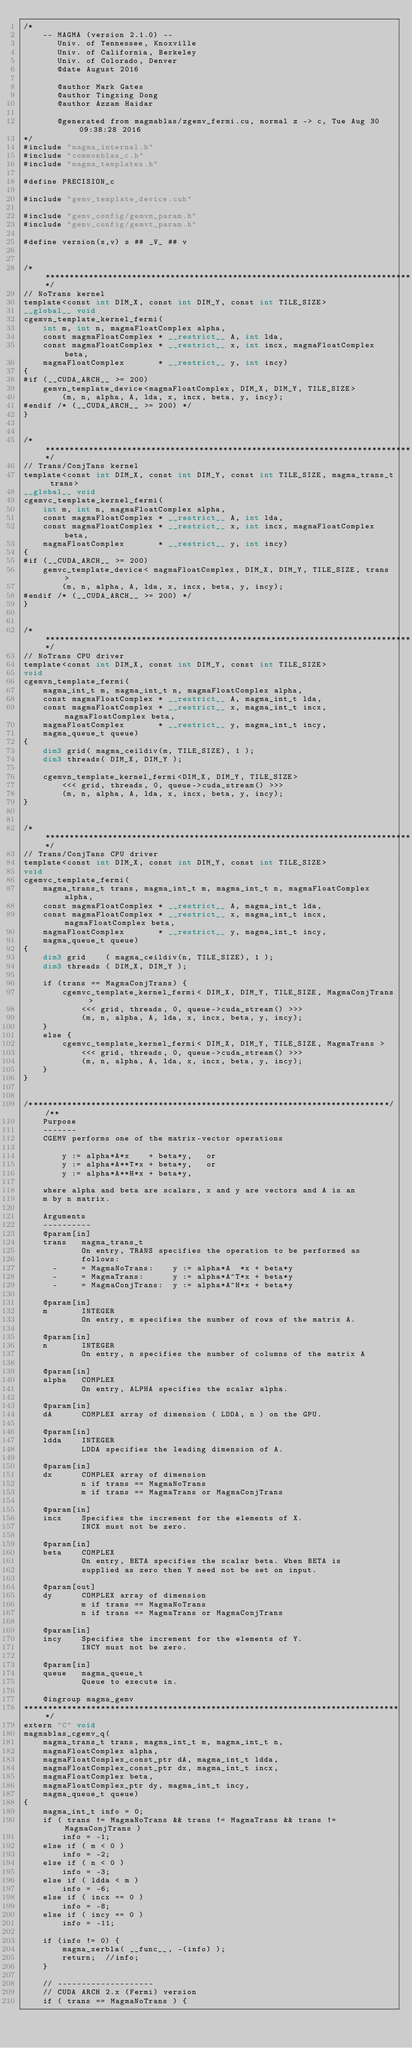Convert code to text. <code><loc_0><loc_0><loc_500><loc_500><_Cuda_>/*
    -- MAGMA (version 2.1.0) --
       Univ. of Tennessee, Knoxville
       Univ. of California, Berkeley
       Univ. of Colorado, Denver
       @date August 2016
       
       @author Mark Gates
       @author Tingxing Dong
       @author Azzam Haidar

       @generated from magmablas/zgemv_fermi.cu, normal z -> c, Tue Aug 30 09:38:28 2016
*/
#include "magma_internal.h"
#include "commonblas_c.h"
#include "magma_templates.h"

#define PRECISION_c

#include "gemv_template_device.cuh"

#include "gemv_config/gemvn_param.h"
#include "gemv_config/gemvt_param.h"

#define version(s,v) s ## _V_ ## v


/******************************************************************************/
// NoTrans kernel
template<const int DIM_X, const int DIM_Y, const int TILE_SIZE>
__global__ void
cgemvn_template_kernel_fermi(
    int m, int n, magmaFloatComplex alpha,
    const magmaFloatComplex * __restrict__ A, int lda,
    const magmaFloatComplex * __restrict__ x, int incx, magmaFloatComplex beta,
    magmaFloatComplex       * __restrict__ y, int incy)
{
#if (__CUDA_ARCH__ >= 200)
    gemvn_template_device<magmaFloatComplex, DIM_X, DIM_Y, TILE_SIZE>
        (m, n, alpha, A, lda, x, incx, beta, y, incy);
#endif /* (__CUDA_ARCH__ >= 200) */
}


/******************************************************************************/
// Trans/ConjTans kernel
template<const int DIM_X, const int DIM_Y, const int TILE_SIZE, magma_trans_t trans>
__global__ void
cgemvc_template_kernel_fermi(
    int m, int n, magmaFloatComplex alpha,
    const magmaFloatComplex * __restrict__ A, int lda,
    const magmaFloatComplex * __restrict__ x, int incx, magmaFloatComplex beta,
    magmaFloatComplex       * __restrict__ y, int incy)
{
#if (__CUDA_ARCH__ >= 200)
    gemvc_template_device< magmaFloatComplex, DIM_X, DIM_Y, TILE_SIZE, trans >
        (m, n, alpha, A, lda, x, incx, beta, y, incy);
#endif /* (__CUDA_ARCH__ >= 200) */
}


/******************************************************************************/
// NoTrans CPU driver
template<const int DIM_X, const int DIM_Y, const int TILE_SIZE>
void
cgemvn_template_fermi(
    magma_int_t m, magma_int_t n, magmaFloatComplex alpha,
    const magmaFloatComplex * __restrict__ A, magma_int_t lda,
    const magmaFloatComplex * __restrict__ x, magma_int_t incx, magmaFloatComplex beta,
    magmaFloatComplex       * __restrict__ y, magma_int_t incy,
    magma_queue_t queue)
{
    dim3 grid( magma_ceildiv(m, TILE_SIZE), 1 );
    dim3 threads( DIM_X, DIM_Y );

    cgemvn_template_kernel_fermi<DIM_X, DIM_Y, TILE_SIZE>
        <<< grid, threads, 0, queue->cuda_stream() >>>
        (m, n, alpha, A, lda, x, incx, beta, y, incy);
}


/******************************************************************************/
// Trans/ConjTans CPU driver
template<const int DIM_X, const int DIM_Y, const int TILE_SIZE>
void
cgemvc_template_fermi(
    magma_trans_t trans, magma_int_t m, magma_int_t n, magmaFloatComplex alpha,
    const magmaFloatComplex * __restrict__ A, magma_int_t lda,
    const magmaFloatComplex * __restrict__ x, magma_int_t incx, magmaFloatComplex beta,
    magmaFloatComplex       * __restrict__ y, magma_int_t incy,
    magma_queue_t queue)
{
    dim3 grid    ( magma_ceildiv(n, TILE_SIZE), 1 );
    dim3 threads ( DIM_X, DIM_Y );
    
    if (trans == MagmaConjTrans) {
        cgemvc_template_kernel_fermi< DIM_X, DIM_Y, TILE_SIZE, MagmaConjTrans >
            <<< grid, threads, 0, queue->cuda_stream() >>>
            (m, n, alpha, A, lda, x, incx, beta, y, incy);
    }
    else {
        cgemvc_template_kernel_fermi< DIM_X, DIM_Y, TILE_SIZE, MagmaTrans >
            <<< grid, threads, 0, queue->cuda_stream() >>>
            (m, n, alpha, A, lda, x, incx, beta, y, incy);
    }
}


/***************************************************************************//**
    Purpose
    -------
    CGEMV performs one of the matrix-vector operations
    
        y := alpha*A*x    + beta*y,   or
        y := alpha*A**T*x + beta*y,   or
        y := alpha*A**H*x + beta*y,
    
    where alpha and beta are scalars, x and y are vectors and A is an
    m by n matrix.

    Arguments
    ----------
    @param[in]
    trans   magma_trans_t
            On entry, TRANS specifies the operation to be performed as
            follows:
      -     = MagmaNoTrans:    y := alpha*A  *x + beta*y
      -     = MagmaTrans:      y := alpha*A^T*x + beta*y
      -     = MagmaConjTrans:  y := alpha*A^H*x + beta*y

    @param[in]
    m       INTEGER
            On entry, m specifies the number of rows of the matrix A.

    @param[in]
    n       INTEGER
            On entry, n specifies the number of columns of the matrix A
 
    @param[in]
    alpha   COMPLEX
            On entry, ALPHA specifies the scalar alpha.

    @param[in]
    dA      COMPLEX array of dimension ( LDDA, n ) on the GPU.
   
    @param[in]
    ldda    INTEGER
            LDDA specifies the leading dimension of A.

    @param[in]
    dx      COMPLEX array of dimension
            n if trans == MagmaNoTrans
            m if trans == MagmaTrans or MagmaConjTrans
     
    @param[in]
    incx    Specifies the increment for the elements of X.
            INCX must not be zero.
  
    @param[in]
    beta    COMPLEX
            On entry, BETA specifies the scalar beta. When BETA is
            supplied as zero then Y need not be set on input.

    @param[out]
    dy      COMPLEX array of dimension
            m if trans == MagmaNoTrans
            n if trans == MagmaTrans or MagmaConjTrans

    @param[in]
    incy    Specifies the increment for the elements of Y.
            INCY must not be zero.

    @param[in]
    queue   magma_queue_t
            Queue to execute in.

    @ingroup magma_gemv
*******************************************************************************/
extern "C" void
magmablas_cgemv_q(
    magma_trans_t trans, magma_int_t m, magma_int_t n, 
    magmaFloatComplex alpha,
    magmaFloatComplex_const_ptr dA, magma_int_t ldda,
    magmaFloatComplex_const_ptr dx, magma_int_t incx,
    magmaFloatComplex beta,
    magmaFloatComplex_ptr dy, magma_int_t incy, 
    magma_queue_t queue)
{
    magma_int_t info = 0;
    if ( trans != MagmaNoTrans && trans != MagmaTrans && trans != MagmaConjTrans )
        info = -1;
    else if ( m < 0 )
        info = -2;
    else if ( n < 0 )
        info = -3;
    else if ( ldda < m )
        info = -6;
    else if ( incx == 0 )
        info = -8;
    else if ( incy == 0 )
        info = -11;
    
    if (info != 0) {
        magma_xerbla( __func__, -(info) );
        return;  //info;
    }

    // --------------------
    // CUDA ARCH 2.x (Fermi) version
    if ( trans == MagmaNoTrans ) {</code> 